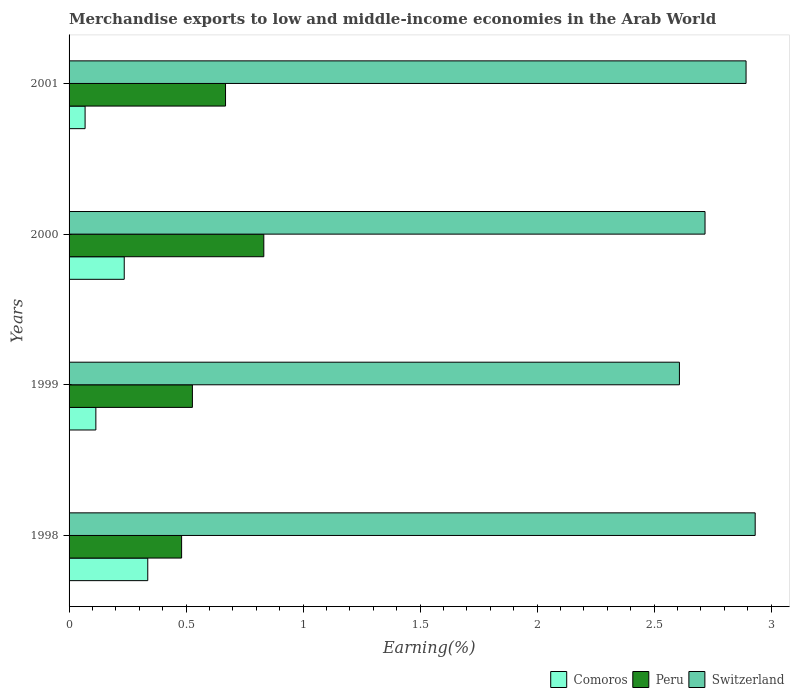How many different coloured bars are there?
Your answer should be compact. 3. How many groups of bars are there?
Your answer should be compact. 4. How many bars are there on the 3rd tick from the top?
Provide a succinct answer. 3. How many bars are there on the 4th tick from the bottom?
Make the answer very short. 3. What is the percentage of amount earned from merchandise exports in Comoros in 1998?
Provide a short and direct response. 0.34. Across all years, what is the maximum percentage of amount earned from merchandise exports in Peru?
Your response must be concise. 0.83. Across all years, what is the minimum percentage of amount earned from merchandise exports in Peru?
Ensure brevity in your answer.  0.48. In which year was the percentage of amount earned from merchandise exports in Comoros maximum?
Offer a terse response. 1998. What is the total percentage of amount earned from merchandise exports in Comoros in the graph?
Your answer should be compact. 0.76. What is the difference between the percentage of amount earned from merchandise exports in Comoros in 2000 and that in 2001?
Your response must be concise. 0.17. What is the difference between the percentage of amount earned from merchandise exports in Switzerland in 2000 and the percentage of amount earned from merchandise exports in Peru in 1998?
Your answer should be very brief. 2.24. What is the average percentage of amount earned from merchandise exports in Comoros per year?
Make the answer very short. 0.19. In the year 1999, what is the difference between the percentage of amount earned from merchandise exports in Comoros and percentage of amount earned from merchandise exports in Switzerland?
Provide a succinct answer. -2.49. In how many years, is the percentage of amount earned from merchandise exports in Comoros greater than 1.3 %?
Keep it short and to the point. 0. What is the ratio of the percentage of amount earned from merchandise exports in Comoros in 1998 to that in 1999?
Make the answer very short. 2.94. Is the percentage of amount earned from merchandise exports in Peru in 1999 less than that in 2001?
Offer a very short reply. Yes. Is the difference between the percentage of amount earned from merchandise exports in Comoros in 1999 and 2000 greater than the difference between the percentage of amount earned from merchandise exports in Switzerland in 1999 and 2000?
Ensure brevity in your answer.  No. What is the difference between the highest and the second highest percentage of amount earned from merchandise exports in Peru?
Your answer should be very brief. 0.16. What is the difference between the highest and the lowest percentage of amount earned from merchandise exports in Comoros?
Your answer should be compact. 0.27. In how many years, is the percentage of amount earned from merchandise exports in Comoros greater than the average percentage of amount earned from merchandise exports in Comoros taken over all years?
Make the answer very short. 2. Is the sum of the percentage of amount earned from merchandise exports in Switzerland in 1998 and 2000 greater than the maximum percentage of amount earned from merchandise exports in Peru across all years?
Ensure brevity in your answer.  Yes. What does the 3rd bar from the top in 2000 represents?
Give a very brief answer. Comoros. What does the 3rd bar from the bottom in 2000 represents?
Your response must be concise. Switzerland. How many years are there in the graph?
Your answer should be compact. 4. What is the difference between two consecutive major ticks on the X-axis?
Make the answer very short. 0.5. Does the graph contain any zero values?
Give a very brief answer. No. Does the graph contain grids?
Your answer should be very brief. No. What is the title of the graph?
Make the answer very short. Merchandise exports to low and middle-income economies in the Arab World. Does "Poland" appear as one of the legend labels in the graph?
Your answer should be compact. No. What is the label or title of the X-axis?
Make the answer very short. Earning(%). What is the label or title of the Y-axis?
Offer a very short reply. Years. What is the Earning(%) of Comoros in 1998?
Offer a terse response. 0.34. What is the Earning(%) in Peru in 1998?
Your response must be concise. 0.48. What is the Earning(%) in Switzerland in 1998?
Make the answer very short. 2.93. What is the Earning(%) in Comoros in 1999?
Give a very brief answer. 0.11. What is the Earning(%) in Peru in 1999?
Your answer should be compact. 0.53. What is the Earning(%) of Switzerland in 1999?
Your answer should be very brief. 2.61. What is the Earning(%) in Comoros in 2000?
Your answer should be very brief. 0.24. What is the Earning(%) of Peru in 2000?
Make the answer very short. 0.83. What is the Earning(%) of Switzerland in 2000?
Your answer should be compact. 2.72. What is the Earning(%) in Comoros in 2001?
Keep it short and to the point. 0.07. What is the Earning(%) in Peru in 2001?
Provide a succinct answer. 0.67. What is the Earning(%) in Switzerland in 2001?
Ensure brevity in your answer.  2.89. Across all years, what is the maximum Earning(%) in Comoros?
Your response must be concise. 0.34. Across all years, what is the maximum Earning(%) of Peru?
Your response must be concise. 0.83. Across all years, what is the maximum Earning(%) in Switzerland?
Provide a short and direct response. 2.93. Across all years, what is the minimum Earning(%) in Comoros?
Offer a terse response. 0.07. Across all years, what is the minimum Earning(%) in Peru?
Make the answer very short. 0.48. Across all years, what is the minimum Earning(%) in Switzerland?
Offer a very short reply. 2.61. What is the total Earning(%) of Comoros in the graph?
Ensure brevity in your answer.  0.76. What is the total Earning(%) in Peru in the graph?
Provide a short and direct response. 2.51. What is the total Earning(%) in Switzerland in the graph?
Give a very brief answer. 11.15. What is the difference between the Earning(%) in Comoros in 1998 and that in 1999?
Ensure brevity in your answer.  0.22. What is the difference between the Earning(%) in Peru in 1998 and that in 1999?
Make the answer very short. -0.05. What is the difference between the Earning(%) of Switzerland in 1998 and that in 1999?
Keep it short and to the point. 0.32. What is the difference between the Earning(%) in Comoros in 1998 and that in 2000?
Offer a very short reply. 0.1. What is the difference between the Earning(%) of Peru in 1998 and that in 2000?
Your answer should be compact. -0.35. What is the difference between the Earning(%) of Switzerland in 1998 and that in 2000?
Your response must be concise. 0.21. What is the difference between the Earning(%) of Comoros in 1998 and that in 2001?
Offer a very short reply. 0.27. What is the difference between the Earning(%) of Peru in 1998 and that in 2001?
Give a very brief answer. -0.19. What is the difference between the Earning(%) in Switzerland in 1998 and that in 2001?
Offer a terse response. 0.04. What is the difference between the Earning(%) in Comoros in 1999 and that in 2000?
Provide a short and direct response. -0.12. What is the difference between the Earning(%) in Peru in 1999 and that in 2000?
Keep it short and to the point. -0.31. What is the difference between the Earning(%) of Switzerland in 1999 and that in 2000?
Ensure brevity in your answer.  -0.11. What is the difference between the Earning(%) of Comoros in 1999 and that in 2001?
Provide a succinct answer. 0.05. What is the difference between the Earning(%) of Peru in 1999 and that in 2001?
Keep it short and to the point. -0.14. What is the difference between the Earning(%) in Switzerland in 1999 and that in 2001?
Provide a succinct answer. -0.28. What is the difference between the Earning(%) of Comoros in 2000 and that in 2001?
Keep it short and to the point. 0.17. What is the difference between the Earning(%) of Peru in 2000 and that in 2001?
Offer a terse response. 0.16. What is the difference between the Earning(%) in Switzerland in 2000 and that in 2001?
Your answer should be very brief. -0.18. What is the difference between the Earning(%) in Comoros in 1998 and the Earning(%) in Peru in 1999?
Your answer should be very brief. -0.19. What is the difference between the Earning(%) of Comoros in 1998 and the Earning(%) of Switzerland in 1999?
Offer a terse response. -2.27. What is the difference between the Earning(%) of Peru in 1998 and the Earning(%) of Switzerland in 1999?
Offer a very short reply. -2.13. What is the difference between the Earning(%) in Comoros in 1998 and the Earning(%) in Peru in 2000?
Make the answer very short. -0.5. What is the difference between the Earning(%) of Comoros in 1998 and the Earning(%) of Switzerland in 2000?
Offer a very short reply. -2.38. What is the difference between the Earning(%) of Peru in 1998 and the Earning(%) of Switzerland in 2000?
Give a very brief answer. -2.24. What is the difference between the Earning(%) of Comoros in 1998 and the Earning(%) of Peru in 2001?
Ensure brevity in your answer.  -0.33. What is the difference between the Earning(%) in Comoros in 1998 and the Earning(%) in Switzerland in 2001?
Your answer should be compact. -2.56. What is the difference between the Earning(%) of Peru in 1998 and the Earning(%) of Switzerland in 2001?
Make the answer very short. -2.41. What is the difference between the Earning(%) in Comoros in 1999 and the Earning(%) in Peru in 2000?
Provide a succinct answer. -0.72. What is the difference between the Earning(%) in Comoros in 1999 and the Earning(%) in Switzerland in 2000?
Offer a terse response. -2.6. What is the difference between the Earning(%) in Peru in 1999 and the Earning(%) in Switzerland in 2000?
Your response must be concise. -2.19. What is the difference between the Earning(%) of Comoros in 1999 and the Earning(%) of Peru in 2001?
Make the answer very short. -0.55. What is the difference between the Earning(%) in Comoros in 1999 and the Earning(%) in Switzerland in 2001?
Ensure brevity in your answer.  -2.78. What is the difference between the Earning(%) in Peru in 1999 and the Earning(%) in Switzerland in 2001?
Make the answer very short. -2.37. What is the difference between the Earning(%) of Comoros in 2000 and the Earning(%) of Peru in 2001?
Keep it short and to the point. -0.43. What is the difference between the Earning(%) of Comoros in 2000 and the Earning(%) of Switzerland in 2001?
Give a very brief answer. -2.66. What is the difference between the Earning(%) of Peru in 2000 and the Earning(%) of Switzerland in 2001?
Provide a succinct answer. -2.06. What is the average Earning(%) of Comoros per year?
Your response must be concise. 0.19. What is the average Earning(%) in Peru per year?
Offer a terse response. 0.63. What is the average Earning(%) of Switzerland per year?
Your answer should be very brief. 2.79. In the year 1998, what is the difference between the Earning(%) in Comoros and Earning(%) in Peru?
Offer a very short reply. -0.14. In the year 1998, what is the difference between the Earning(%) in Comoros and Earning(%) in Switzerland?
Offer a very short reply. -2.6. In the year 1998, what is the difference between the Earning(%) of Peru and Earning(%) of Switzerland?
Offer a terse response. -2.45. In the year 1999, what is the difference between the Earning(%) of Comoros and Earning(%) of Peru?
Your answer should be compact. -0.41. In the year 1999, what is the difference between the Earning(%) of Comoros and Earning(%) of Switzerland?
Offer a very short reply. -2.49. In the year 1999, what is the difference between the Earning(%) in Peru and Earning(%) in Switzerland?
Your response must be concise. -2.08. In the year 2000, what is the difference between the Earning(%) in Comoros and Earning(%) in Peru?
Offer a very short reply. -0.6. In the year 2000, what is the difference between the Earning(%) of Comoros and Earning(%) of Switzerland?
Your answer should be compact. -2.48. In the year 2000, what is the difference between the Earning(%) in Peru and Earning(%) in Switzerland?
Your answer should be very brief. -1.89. In the year 2001, what is the difference between the Earning(%) in Comoros and Earning(%) in Peru?
Keep it short and to the point. -0.6. In the year 2001, what is the difference between the Earning(%) of Comoros and Earning(%) of Switzerland?
Your answer should be compact. -2.82. In the year 2001, what is the difference between the Earning(%) of Peru and Earning(%) of Switzerland?
Offer a terse response. -2.22. What is the ratio of the Earning(%) in Comoros in 1998 to that in 1999?
Your answer should be very brief. 2.94. What is the ratio of the Earning(%) in Peru in 1998 to that in 1999?
Offer a very short reply. 0.91. What is the ratio of the Earning(%) of Switzerland in 1998 to that in 1999?
Make the answer very short. 1.12. What is the ratio of the Earning(%) of Comoros in 1998 to that in 2000?
Offer a very short reply. 1.43. What is the ratio of the Earning(%) of Peru in 1998 to that in 2000?
Make the answer very short. 0.58. What is the ratio of the Earning(%) in Switzerland in 1998 to that in 2000?
Your answer should be compact. 1.08. What is the ratio of the Earning(%) in Comoros in 1998 to that in 2001?
Your answer should be very brief. 4.91. What is the ratio of the Earning(%) of Peru in 1998 to that in 2001?
Offer a terse response. 0.72. What is the ratio of the Earning(%) in Switzerland in 1998 to that in 2001?
Offer a terse response. 1.01. What is the ratio of the Earning(%) in Comoros in 1999 to that in 2000?
Your answer should be very brief. 0.49. What is the ratio of the Earning(%) of Peru in 1999 to that in 2000?
Offer a very short reply. 0.63. What is the ratio of the Earning(%) of Switzerland in 1999 to that in 2000?
Keep it short and to the point. 0.96. What is the ratio of the Earning(%) of Comoros in 1999 to that in 2001?
Make the answer very short. 1.67. What is the ratio of the Earning(%) of Peru in 1999 to that in 2001?
Provide a succinct answer. 0.79. What is the ratio of the Earning(%) of Switzerland in 1999 to that in 2001?
Provide a succinct answer. 0.9. What is the ratio of the Earning(%) in Comoros in 2000 to that in 2001?
Make the answer very short. 3.44. What is the ratio of the Earning(%) of Peru in 2000 to that in 2001?
Offer a terse response. 1.24. What is the ratio of the Earning(%) in Switzerland in 2000 to that in 2001?
Provide a short and direct response. 0.94. What is the difference between the highest and the second highest Earning(%) in Comoros?
Make the answer very short. 0.1. What is the difference between the highest and the second highest Earning(%) of Peru?
Provide a succinct answer. 0.16. What is the difference between the highest and the second highest Earning(%) in Switzerland?
Ensure brevity in your answer.  0.04. What is the difference between the highest and the lowest Earning(%) of Comoros?
Offer a terse response. 0.27. What is the difference between the highest and the lowest Earning(%) in Peru?
Provide a short and direct response. 0.35. What is the difference between the highest and the lowest Earning(%) of Switzerland?
Offer a terse response. 0.32. 